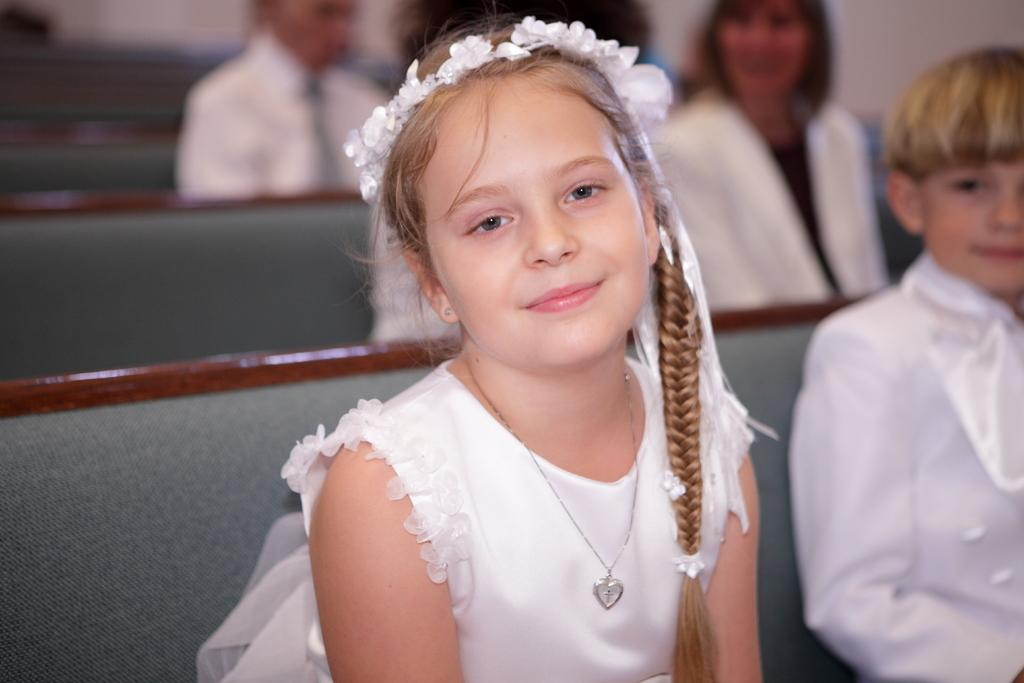What are the people in the image doing? The people in the image are sitting. What color are the dresses worn by the people in the image? The people are wearing white color dresses. Can you describe the background of the image? The background of the image is blurry. What type of brick is being used to build the cabbage in the image? There is no brick or cabbage present in the image; it only features people sitting in white dresses with a blurry background. 